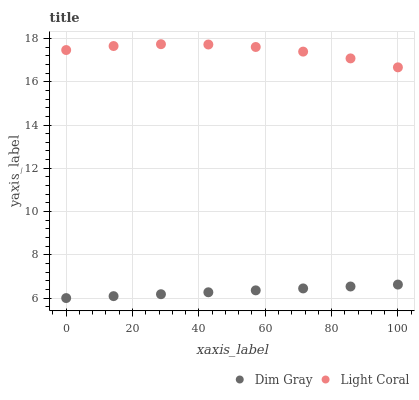Does Dim Gray have the minimum area under the curve?
Answer yes or no. Yes. Does Light Coral have the maximum area under the curve?
Answer yes or no. Yes. Does Dim Gray have the maximum area under the curve?
Answer yes or no. No. Is Dim Gray the smoothest?
Answer yes or no. Yes. Is Light Coral the roughest?
Answer yes or no. Yes. Is Dim Gray the roughest?
Answer yes or no. No. Does Dim Gray have the lowest value?
Answer yes or no. Yes. Does Light Coral have the highest value?
Answer yes or no. Yes. Does Dim Gray have the highest value?
Answer yes or no. No. Is Dim Gray less than Light Coral?
Answer yes or no. Yes. Is Light Coral greater than Dim Gray?
Answer yes or no. Yes. Does Dim Gray intersect Light Coral?
Answer yes or no. No. 